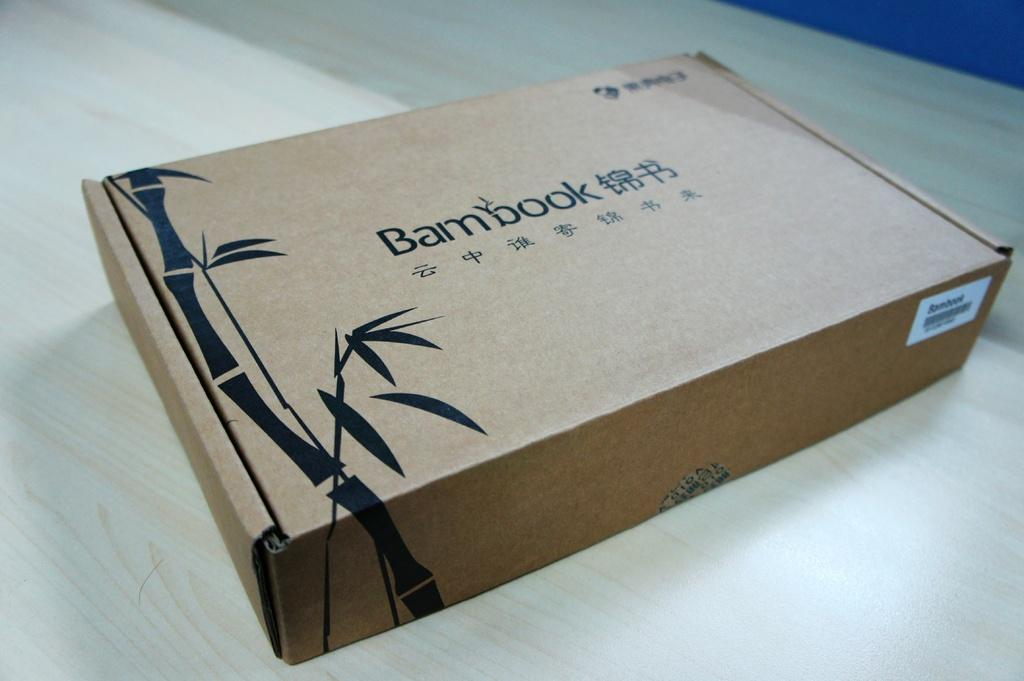<image>
Write a terse but informative summary of the picture. A box with BamBook on the outside of the box. 